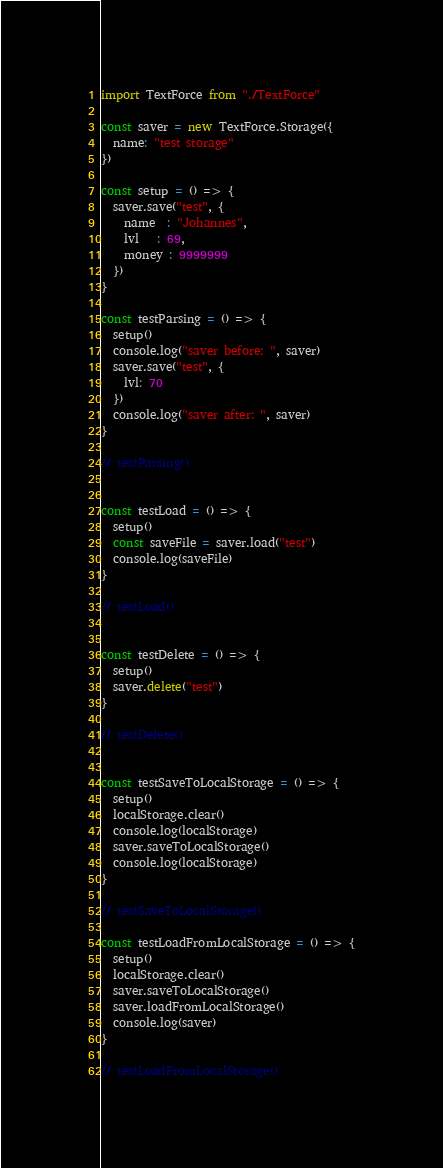Convert code to text. <code><loc_0><loc_0><loc_500><loc_500><_JavaScript_>import TextForce from "./TextForce"

const saver = new TextForce.Storage({
  name: "test storage"
})

const setup = () => {
  saver.save("test", {
    name  : "Johannes",
    lvl   : 69,
    money : 9999999
  })
}

const testParsing = () => {
  setup()
  console.log("saver before: ", saver)
  saver.save("test", {
    lvl: 70
  })
  console.log("saver after: ", saver)
}

// testParsing()


const testLoad = () => {
  setup()
  const saveFile = saver.load("test")
  console.log(saveFile)
}

// testLoad()


const testDelete = () => {
  setup()
  saver.delete("test")
}

// testDelete()


const testSaveToLocalStorage = () => {
  setup()
  localStorage.clear()
  console.log(localStorage)
  saver.saveToLocalStorage()
  console.log(localStorage)
}

// testSaveToLocalStorage()

const testLoadFromLocalStorage = () => {
  setup()
  localStorage.clear()
  saver.saveToLocalStorage()
  saver.loadFromLocalStorage()
  console.log(saver)
}

// testLoadFromLocalStorage()
</code> 